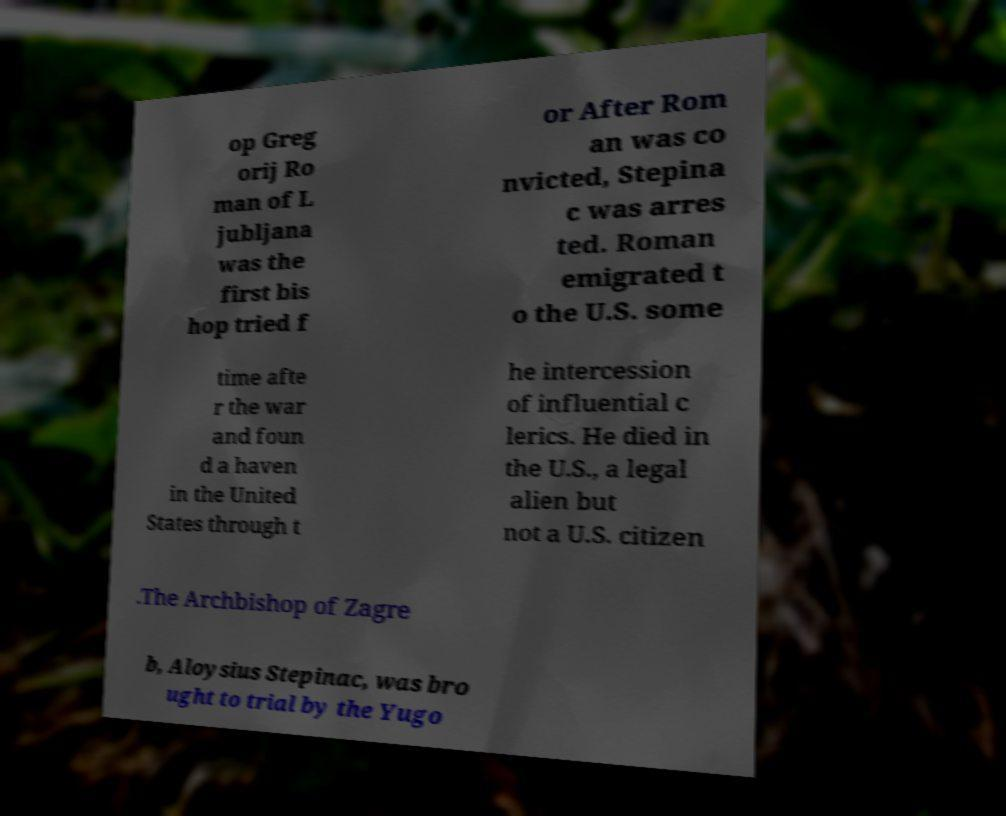Could you extract and type out the text from this image? op Greg orij Ro man of L jubljana was the first bis hop tried f or After Rom an was co nvicted, Stepina c was arres ted. Roman emigrated t o the U.S. some time afte r the war and foun d a haven in the United States through t he intercession of influential c lerics. He died in the U.S., a legal alien but not a U.S. citizen .The Archbishop of Zagre b, Aloysius Stepinac, was bro ught to trial by the Yugo 